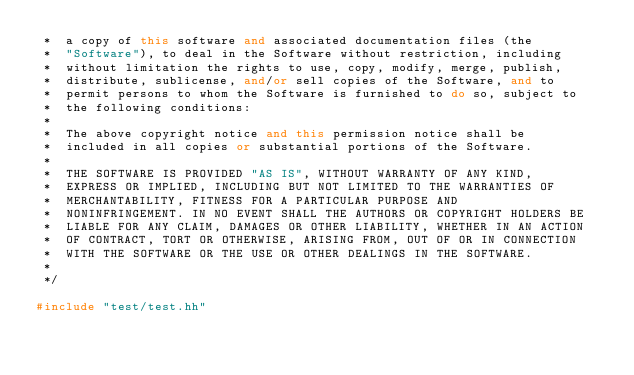<code> <loc_0><loc_0><loc_500><loc_500><_C++_> *  a copy of this software and associated documentation files (the
 *  "Software"), to deal in the Software without restriction, including
 *  without limitation the rights to use, copy, modify, merge, publish,
 *  distribute, sublicense, and/or sell copies of the Software, and to
 *  permit persons to whom the Software is furnished to do so, subject to
 *  the following conditions:
 *
 *  The above copyright notice and this permission notice shall be
 *  included in all copies or substantial portions of the Software.
 *
 *  THE SOFTWARE IS PROVIDED "AS IS", WITHOUT WARRANTY OF ANY KIND,
 *  EXPRESS OR IMPLIED, INCLUDING BUT NOT LIMITED TO THE WARRANTIES OF
 *  MERCHANTABILITY, FITNESS FOR A PARTICULAR PURPOSE AND
 *  NONINFRINGEMENT. IN NO EVENT SHALL THE AUTHORS OR COPYRIGHT HOLDERS BE
 *  LIABLE FOR ANY CLAIM, DAMAGES OR OTHER LIABILITY, WHETHER IN AN ACTION
 *  OF CONTRACT, TORT OR OTHERWISE, ARISING FROM, OUT OF OR IN CONNECTION
 *  WITH THE SOFTWARE OR THE USE OR OTHER DEALINGS IN THE SOFTWARE.
 *
 */

#include "test/test.hh"
</code> 